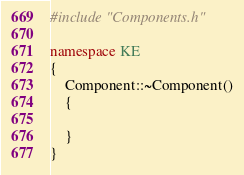<code> <loc_0><loc_0><loc_500><loc_500><_C++_>#include "Components.h"

namespace KE
{
	Component::~Component()
	{

	}
}</code> 